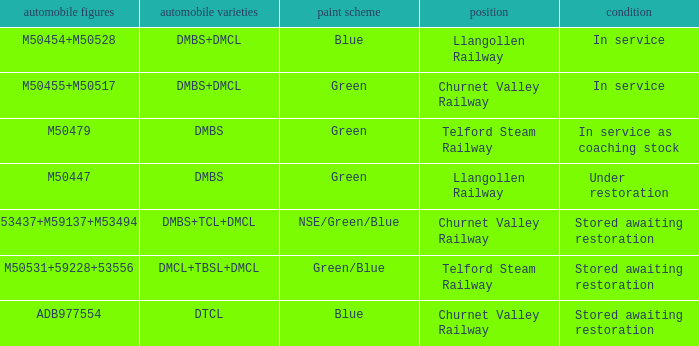What status is the vehicle numbers of adb977554? Stored awaiting restoration. 